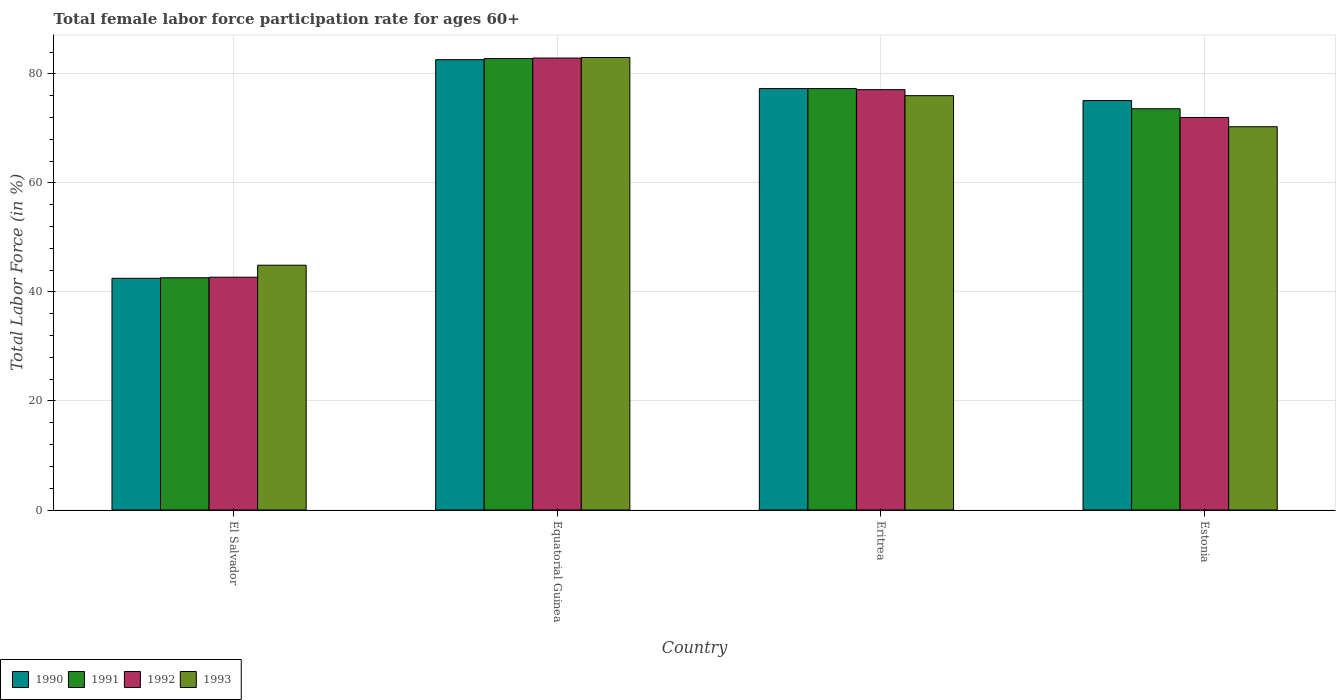How many groups of bars are there?
Give a very brief answer. 4. Are the number of bars per tick equal to the number of legend labels?
Your response must be concise. Yes. How many bars are there on the 4th tick from the right?
Give a very brief answer. 4. What is the label of the 1st group of bars from the left?
Ensure brevity in your answer.  El Salvador. In how many cases, is the number of bars for a given country not equal to the number of legend labels?
Keep it short and to the point. 0. What is the female labor force participation rate in 1991 in Estonia?
Provide a short and direct response. 73.6. Across all countries, what is the minimum female labor force participation rate in 1992?
Your answer should be compact. 42.7. In which country was the female labor force participation rate in 1990 maximum?
Ensure brevity in your answer.  Equatorial Guinea. In which country was the female labor force participation rate in 1990 minimum?
Offer a terse response. El Salvador. What is the total female labor force participation rate in 1992 in the graph?
Make the answer very short. 274.7. What is the difference between the female labor force participation rate in 1992 in El Salvador and that in Eritrea?
Your response must be concise. -34.4. What is the difference between the female labor force participation rate in 1990 in Equatorial Guinea and the female labor force participation rate in 1991 in Estonia?
Your response must be concise. 9. What is the average female labor force participation rate in 1991 per country?
Your response must be concise. 69.08. What is the difference between the female labor force participation rate of/in 1992 and female labor force participation rate of/in 1993 in Eritrea?
Provide a succinct answer. 1.1. In how many countries, is the female labor force participation rate in 1993 greater than 76 %?
Your answer should be compact. 1. What is the ratio of the female labor force participation rate in 1992 in Equatorial Guinea to that in Estonia?
Keep it short and to the point. 1.15. What is the difference between the highest and the second highest female labor force participation rate in 1990?
Ensure brevity in your answer.  7.5. What is the difference between the highest and the lowest female labor force participation rate in 1993?
Keep it short and to the point. 38.1. Is the sum of the female labor force participation rate in 1990 in Equatorial Guinea and Eritrea greater than the maximum female labor force participation rate in 1992 across all countries?
Ensure brevity in your answer.  Yes. Is it the case that in every country, the sum of the female labor force participation rate in 1993 and female labor force participation rate in 1991 is greater than the sum of female labor force participation rate in 1990 and female labor force participation rate in 1992?
Ensure brevity in your answer.  No. Is it the case that in every country, the sum of the female labor force participation rate in 1990 and female labor force participation rate in 1991 is greater than the female labor force participation rate in 1993?
Keep it short and to the point. Yes. Are the values on the major ticks of Y-axis written in scientific E-notation?
Offer a very short reply. No. Does the graph contain any zero values?
Give a very brief answer. No. Where does the legend appear in the graph?
Provide a succinct answer. Bottom left. How many legend labels are there?
Ensure brevity in your answer.  4. What is the title of the graph?
Provide a short and direct response. Total female labor force participation rate for ages 60+. Does "1967" appear as one of the legend labels in the graph?
Make the answer very short. No. What is the label or title of the X-axis?
Ensure brevity in your answer.  Country. What is the Total Labor Force (in %) of 1990 in El Salvador?
Your answer should be compact. 42.5. What is the Total Labor Force (in %) in 1991 in El Salvador?
Offer a terse response. 42.6. What is the Total Labor Force (in %) of 1992 in El Salvador?
Your response must be concise. 42.7. What is the Total Labor Force (in %) of 1993 in El Salvador?
Offer a terse response. 44.9. What is the Total Labor Force (in %) in 1990 in Equatorial Guinea?
Offer a very short reply. 82.6. What is the Total Labor Force (in %) in 1991 in Equatorial Guinea?
Your answer should be very brief. 82.8. What is the Total Labor Force (in %) in 1992 in Equatorial Guinea?
Provide a succinct answer. 82.9. What is the Total Labor Force (in %) of 1990 in Eritrea?
Provide a succinct answer. 77.3. What is the Total Labor Force (in %) in 1991 in Eritrea?
Give a very brief answer. 77.3. What is the Total Labor Force (in %) in 1992 in Eritrea?
Keep it short and to the point. 77.1. What is the Total Labor Force (in %) of 1990 in Estonia?
Offer a terse response. 75.1. What is the Total Labor Force (in %) of 1991 in Estonia?
Your response must be concise. 73.6. What is the Total Labor Force (in %) in 1992 in Estonia?
Your answer should be very brief. 72. What is the Total Labor Force (in %) in 1993 in Estonia?
Give a very brief answer. 70.3. Across all countries, what is the maximum Total Labor Force (in %) of 1990?
Give a very brief answer. 82.6. Across all countries, what is the maximum Total Labor Force (in %) in 1991?
Your answer should be compact. 82.8. Across all countries, what is the maximum Total Labor Force (in %) in 1992?
Make the answer very short. 82.9. Across all countries, what is the maximum Total Labor Force (in %) in 1993?
Provide a short and direct response. 83. Across all countries, what is the minimum Total Labor Force (in %) of 1990?
Offer a very short reply. 42.5. Across all countries, what is the minimum Total Labor Force (in %) of 1991?
Provide a succinct answer. 42.6. Across all countries, what is the minimum Total Labor Force (in %) of 1992?
Provide a short and direct response. 42.7. Across all countries, what is the minimum Total Labor Force (in %) in 1993?
Offer a very short reply. 44.9. What is the total Total Labor Force (in %) of 1990 in the graph?
Provide a succinct answer. 277.5. What is the total Total Labor Force (in %) of 1991 in the graph?
Provide a short and direct response. 276.3. What is the total Total Labor Force (in %) in 1992 in the graph?
Provide a succinct answer. 274.7. What is the total Total Labor Force (in %) of 1993 in the graph?
Provide a short and direct response. 274.2. What is the difference between the Total Labor Force (in %) of 1990 in El Salvador and that in Equatorial Guinea?
Provide a short and direct response. -40.1. What is the difference between the Total Labor Force (in %) in 1991 in El Salvador and that in Equatorial Guinea?
Give a very brief answer. -40.2. What is the difference between the Total Labor Force (in %) in 1992 in El Salvador and that in Equatorial Guinea?
Provide a succinct answer. -40.2. What is the difference between the Total Labor Force (in %) in 1993 in El Salvador and that in Equatorial Guinea?
Offer a very short reply. -38.1. What is the difference between the Total Labor Force (in %) in 1990 in El Salvador and that in Eritrea?
Keep it short and to the point. -34.8. What is the difference between the Total Labor Force (in %) of 1991 in El Salvador and that in Eritrea?
Give a very brief answer. -34.7. What is the difference between the Total Labor Force (in %) in 1992 in El Salvador and that in Eritrea?
Give a very brief answer. -34.4. What is the difference between the Total Labor Force (in %) in 1993 in El Salvador and that in Eritrea?
Provide a succinct answer. -31.1. What is the difference between the Total Labor Force (in %) in 1990 in El Salvador and that in Estonia?
Offer a very short reply. -32.6. What is the difference between the Total Labor Force (in %) in 1991 in El Salvador and that in Estonia?
Offer a very short reply. -31. What is the difference between the Total Labor Force (in %) of 1992 in El Salvador and that in Estonia?
Make the answer very short. -29.3. What is the difference between the Total Labor Force (in %) in 1993 in El Salvador and that in Estonia?
Ensure brevity in your answer.  -25.4. What is the difference between the Total Labor Force (in %) in 1990 in Equatorial Guinea and that in Eritrea?
Offer a terse response. 5.3. What is the difference between the Total Labor Force (in %) in 1992 in Equatorial Guinea and that in Eritrea?
Offer a terse response. 5.8. What is the difference between the Total Labor Force (in %) in 1991 in Equatorial Guinea and that in Estonia?
Keep it short and to the point. 9.2. What is the difference between the Total Labor Force (in %) in 1993 in Equatorial Guinea and that in Estonia?
Make the answer very short. 12.7. What is the difference between the Total Labor Force (in %) in 1990 in Eritrea and that in Estonia?
Make the answer very short. 2.2. What is the difference between the Total Labor Force (in %) of 1993 in Eritrea and that in Estonia?
Your response must be concise. 5.7. What is the difference between the Total Labor Force (in %) of 1990 in El Salvador and the Total Labor Force (in %) of 1991 in Equatorial Guinea?
Offer a very short reply. -40.3. What is the difference between the Total Labor Force (in %) of 1990 in El Salvador and the Total Labor Force (in %) of 1992 in Equatorial Guinea?
Your response must be concise. -40.4. What is the difference between the Total Labor Force (in %) in 1990 in El Salvador and the Total Labor Force (in %) in 1993 in Equatorial Guinea?
Give a very brief answer. -40.5. What is the difference between the Total Labor Force (in %) of 1991 in El Salvador and the Total Labor Force (in %) of 1992 in Equatorial Guinea?
Ensure brevity in your answer.  -40.3. What is the difference between the Total Labor Force (in %) of 1991 in El Salvador and the Total Labor Force (in %) of 1993 in Equatorial Guinea?
Offer a terse response. -40.4. What is the difference between the Total Labor Force (in %) of 1992 in El Salvador and the Total Labor Force (in %) of 1993 in Equatorial Guinea?
Provide a succinct answer. -40.3. What is the difference between the Total Labor Force (in %) of 1990 in El Salvador and the Total Labor Force (in %) of 1991 in Eritrea?
Give a very brief answer. -34.8. What is the difference between the Total Labor Force (in %) of 1990 in El Salvador and the Total Labor Force (in %) of 1992 in Eritrea?
Ensure brevity in your answer.  -34.6. What is the difference between the Total Labor Force (in %) in 1990 in El Salvador and the Total Labor Force (in %) in 1993 in Eritrea?
Your answer should be compact. -33.5. What is the difference between the Total Labor Force (in %) of 1991 in El Salvador and the Total Labor Force (in %) of 1992 in Eritrea?
Your answer should be compact. -34.5. What is the difference between the Total Labor Force (in %) in 1991 in El Salvador and the Total Labor Force (in %) in 1993 in Eritrea?
Make the answer very short. -33.4. What is the difference between the Total Labor Force (in %) in 1992 in El Salvador and the Total Labor Force (in %) in 1993 in Eritrea?
Ensure brevity in your answer.  -33.3. What is the difference between the Total Labor Force (in %) in 1990 in El Salvador and the Total Labor Force (in %) in 1991 in Estonia?
Your answer should be very brief. -31.1. What is the difference between the Total Labor Force (in %) of 1990 in El Salvador and the Total Labor Force (in %) of 1992 in Estonia?
Offer a very short reply. -29.5. What is the difference between the Total Labor Force (in %) in 1990 in El Salvador and the Total Labor Force (in %) in 1993 in Estonia?
Offer a terse response. -27.8. What is the difference between the Total Labor Force (in %) of 1991 in El Salvador and the Total Labor Force (in %) of 1992 in Estonia?
Ensure brevity in your answer.  -29.4. What is the difference between the Total Labor Force (in %) of 1991 in El Salvador and the Total Labor Force (in %) of 1993 in Estonia?
Offer a very short reply. -27.7. What is the difference between the Total Labor Force (in %) in 1992 in El Salvador and the Total Labor Force (in %) in 1993 in Estonia?
Offer a very short reply. -27.6. What is the difference between the Total Labor Force (in %) in 1992 in Equatorial Guinea and the Total Labor Force (in %) in 1993 in Eritrea?
Keep it short and to the point. 6.9. What is the difference between the Total Labor Force (in %) of 1990 in Equatorial Guinea and the Total Labor Force (in %) of 1993 in Estonia?
Keep it short and to the point. 12.3. What is the difference between the Total Labor Force (in %) of 1991 in Equatorial Guinea and the Total Labor Force (in %) of 1992 in Estonia?
Provide a succinct answer. 10.8. What is the difference between the Total Labor Force (in %) in 1992 in Equatorial Guinea and the Total Labor Force (in %) in 1993 in Estonia?
Make the answer very short. 12.6. What is the difference between the Total Labor Force (in %) of 1990 in Eritrea and the Total Labor Force (in %) of 1992 in Estonia?
Provide a succinct answer. 5.3. What is the difference between the Total Labor Force (in %) in 1991 in Eritrea and the Total Labor Force (in %) in 1992 in Estonia?
Offer a very short reply. 5.3. What is the difference between the Total Labor Force (in %) in 1992 in Eritrea and the Total Labor Force (in %) in 1993 in Estonia?
Offer a very short reply. 6.8. What is the average Total Labor Force (in %) of 1990 per country?
Your answer should be very brief. 69.38. What is the average Total Labor Force (in %) of 1991 per country?
Keep it short and to the point. 69.08. What is the average Total Labor Force (in %) of 1992 per country?
Offer a terse response. 68.67. What is the average Total Labor Force (in %) in 1993 per country?
Ensure brevity in your answer.  68.55. What is the difference between the Total Labor Force (in %) in 1990 and Total Labor Force (in %) in 1991 in El Salvador?
Keep it short and to the point. -0.1. What is the difference between the Total Labor Force (in %) of 1990 and Total Labor Force (in %) of 1993 in El Salvador?
Keep it short and to the point. -2.4. What is the difference between the Total Labor Force (in %) of 1991 and Total Labor Force (in %) of 1992 in El Salvador?
Your response must be concise. -0.1. What is the difference between the Total Labor Force (in %) in 1992 and Total Labor Force (in %) in 1993 in El Salvador?
Keep it short and to the point. -2.2. What is the difference between the Total Labor Force (in %) in 1991 and Total Labor Force (in %) in 1992 in Equatorial Guinea?
Make the answer very short. -0.1. What is the difference between the Total Labor Force (in %) of 1990 and Total Labor Force (in %) of 1993 in Eritrea?
Offer a terse response. 1.3. What is the difference between the Total Labor Force (in %) in 1991 and Total Labor Force (in %) in 1993 in Eritrea?
Keep it short and to the point. 1.3. What is the difference between the Total Labor Force (in %) in 1992 and Total Labor Force (in %) in 1993 in Eritrea?
Provide a short and direct response. 1.1. What is the difference between the Total Labor Force (in %) of 1990 and Total Labor Force (in %) of 1993 in Estonia?
Provide a succinct answer. 4.8. What is the difference between the Total Labor Force (in %) of 1991 and Total Labor Force (in %) of 1992 in Estonia?
Make the answer very short. 1.6. What is the difference between the Total Labor Force (in %) in 1992 and Total Labor Force (in %) in 1993 in Estonia?
Your response must be concise. 1.7. What is the ratio of the Total Labor Force (in %) in 1990 in El Salvador to that in Equatorial Guinea?
Offer a terse response. 0.51. What is the ratio of the Total Labor Force (in %) of 1991 in El Salvador to that in Equatorial Guinea?
Offer a terse response. 0.51. What is the ratio of the Total Labor Force (in %) in 1992 in El Salvador to that in Equatorial Guinea?
Your response must be concise. 0.52. What is the ratio of the Total Labor Force (in %) of 1993 in El Salvador to that in Equatorial Guinea?
Offer a terse response. 0.54. What is the ratio of the Total Labor Force (in %) in 1990 in El Salvador to that in Eritrea?
Offer a very short reply. 0.55. What is the ratio of the Total Labor Force (in %) of 1991 in El Salvador to that in Eritrea?
Ensure brevity in your answer.  0.55. What is the ratio of the Total Labor Force (in %) of 1992 in El Salvador to that in Eritrea?
Keep it short and to the point. 0.55. What is the ratio of the Total Labor Force (in %) in 1993 in El Salvador to that in Eritrea?
Keep it short and to the point. 0.59. What is the ratio of the Total Labor Force (in %) of 1990 in El Salvador to that in Estonia?
Offer a terse response. 0.57. What is the ratio of the Total Labor Force (in %) in 1991 in El Salvador to that in Estonia?
Make the answer very short. 0.58. What is the ratio of the Total Labor Force (in %) in 1992 in El Salvador to that in Estonia?
Provide a succinct answer. 0.59. What is the ratio of the Total Labor Force (in %) in 1993 in El Salvador to that in Estonia?
Your answer should be compact. 0.64. What is the ratio of the Total Labor Force (in %) in 1990 in Equatorial Guinea to that in Eritrea?
Your answer should be very brief. 1.07. What is the ratio of the Total Labor Force (in %) in 1991 in Equatorial Guinea to that in Eritrea?
Your answer should be very brief. 1.07. What is the ratio of the Total Labor Force (in %) in 1992 in Equatorial Guinea to that in Eritrea?
Offer a terse response. 1.08. What is the ratio of the Total Labor Force (in %) of 1993 in Equatorial Guinea to that in Eritrea?
Provide a succinct answer. 1.09. What is the ratio of the Total Labor Force (in %) in 1990 in Equatorial Guinea to that in Estonia?
Your response must be concise. 1.1. What is the ratio of the Total Labor Force (in %) in 1991 in Equatorial Guinea to that in Estonia?
Offer a terse response. 1.12. What is the ratio of the Total Labor Force (in %) in 1992 in Equatorial Guinea to that in Estonia?
Provide a succinct answer. 1.15. What is the ratio of the Total Labor Force (in %) in 1993 in Equatorial Guinea to that in Estonia?
Provide a succinct answer. 1.18. What is the ratio of the Total Labor Force (in %) in 1990 in Eritrea to that in Estonia?
Ensure brevity in your answer.  1.03. What is the ratio of the Total Labor Force (in %) of 1991 in Eritrea to that in Estonia?
Offer a terse response. 1.05. What is the ratio of the Total Labor Force (in %) of 1992 in Eritrea to that in Estonia?
Your answer should be very brief. 1.07. What is the ratio of the Total Labor Force (in %) of 1993 in Eritrea to that in Estonia?
Offer a terse response. 1.08. What is the difference between the highest and the second highest Total Labor Force (in %) in 1993?
Your answer should be compact. 7. What is the difference between the highest and the lowest Total Labor Force (in %) of 1990?
Your response must be concise. 40.1. What is the difference between the highest and the lowest Total Labor Force (in %) in 1991?
Your answer should be very brief. 40.2. What is the difference between the highest and the lowest Total Labor Force (in %) in 1992?
Your answer should be very brief. 40.2. What is the difference between the highest and the lowest Total Labor Force (in %) of 1993?
Ensure brevity in your answer.  38.1. 